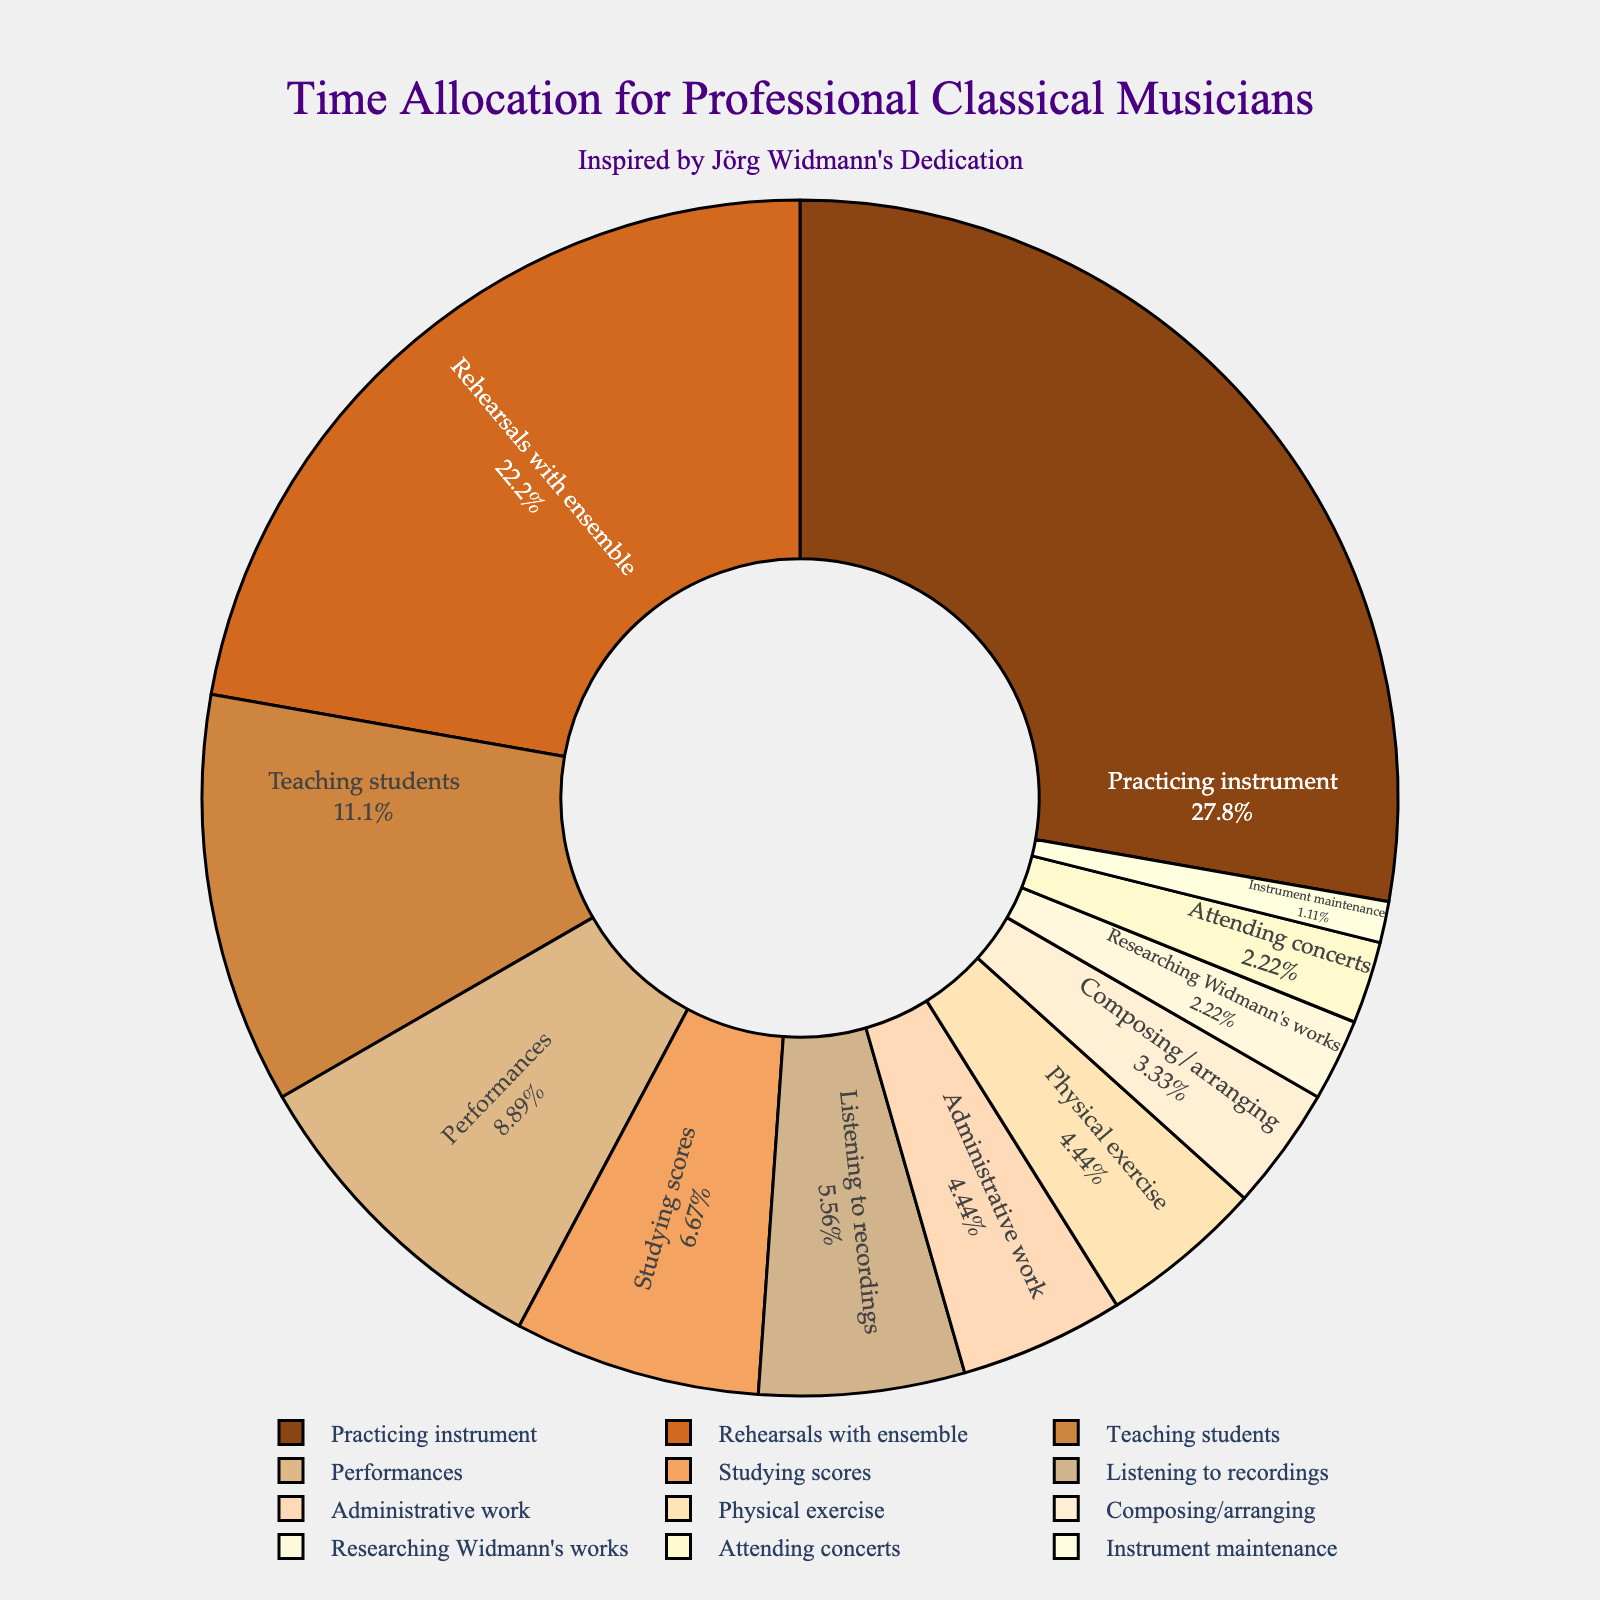How much time is dedicated to exercising compared to researching Widmann's works? According to the pie chart, physical exercise accounts for 4 hours per week while researching Widmann's works is 2 hours per week. Therefore, 4 hours / 2 hours = 2 times more time is dedicated to exercising compared to researching Widmann's works.
Answer: 2 times Which activity occupies the smallest percentage of time? By looking at the pie chart, it is evident that instrument maintenance is the activity with the smallest slice. It accounts for the least hours of the week, which is 1 hour.
Answer: Instrument maintenance What's the total percentage of time spent on practicing instrument, rehearsals with ensemble, and performances combined? The pie chart shows that practicing instrument takes 25 hours, rehearsals take 20 hours, and performances take 8 hours. Summing these up gives 25 + 20 + 8 = 53 hours. To find the percentage, we sum the individual percentages from the chart: \( \frac{25}{90} \times 100 + \frac{20}{90} \times 100 + \frac{8}{90} \times 100 = 27.8 % + 22.2 % + 8.9 % = 58.9 % \)
Answer: 58.9% How does the time spent on teaching students compare to the time spent on studying scores? According to the pie chart, teaching students accounts for 10 hours per week, and studying scores accounts for 6 hours per week. Therefore, teaching students occupies more time, specifically \( \frac{10}{6} = 1.67 \) times more than studying scores.
Answer: 1.67 times Are attending concerts and researching Widmann's works allocated the same amount of time? From the pie chart, attending concerts takes 2 hours per week, which is the same amount of time as allocated to researching Widmann's works.
Answer: Yes Which color represents the activity that includes the highest percentage of time? Practicing instrument takes the highest percentage of time. By visually inspecting the pie chart, practicing instrument is represented by the darkest color, likely a rich brown or a similar shade.
Answer: Rich brown What is the difference in the percentage of time spent practicing the instrument versus teaching students? Practicing instrument takes 25 hours, and teaching students take 10 hours. The percentage of time each activity takes is given by \( \frac{25}{90} \times 100 \approx 27.8% \) for practicing and \( \frac{10}{90} \times 100 \approx 11.1% \) for teaching. The difference is \( 27.8% - 11.1% = 16.7% \).
Answer: 16.7% How many different activities occupy more than 10% of a musician’s weekly time? From the pie chart, we can see practicing instrument and rehearsals with ensemble occupy 27.8% and 22.2% respectively, each more than 10%. Therefore, there are 2 activities occupying more than 10% of the weekly time.
Answer: 2 activities 